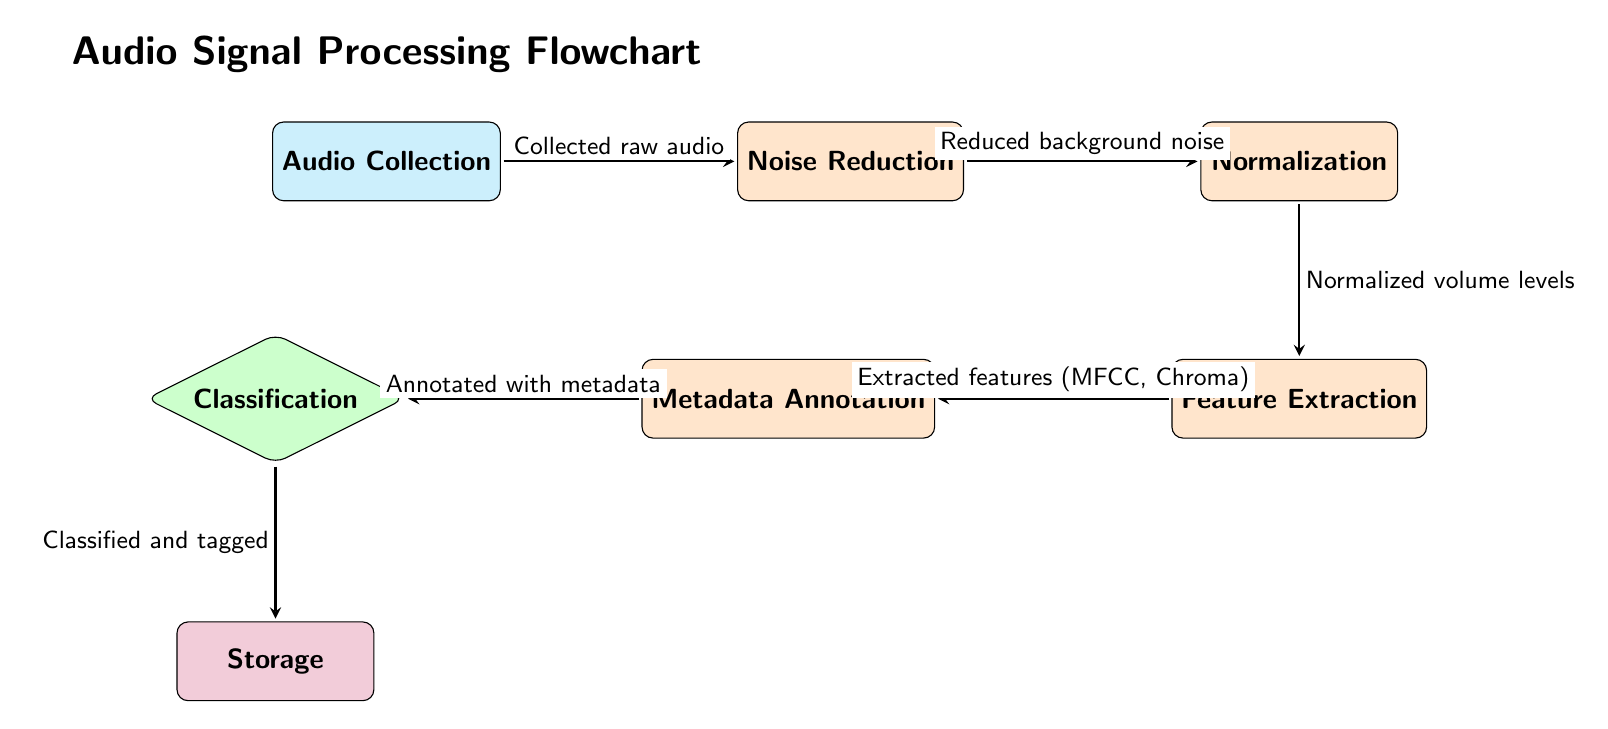What is the first step in the audio processing flow? The first step is "Audio Collection," as indicated by the leftmost node in the diagram.
Answer: Audio Collection How many processes are involved in this flowchart? There are four processes shown: Noise Reduction, Normalization, Feature Extraction, and Metadata Annotation, which can be counted directly from the process nodes.
Answer: 4 What is the output after classification? The output after classification is "Storage," which is the final node in the diagram connected to the classification decision node.
Answer: Storage Which process follows noise reduction? Following noise reduction, the next process is "Normalization," which is directly to the right of "Noise Reduction" in the flowchart.
Answer: Normalization What type of node is "Classification"? "Classification" is a decision node, indicated by its diamond shape and color in the diagram.
Answer: Decision What kind of features are extracted during the feature extraction process? The features extracted during this process are "MFCC" and "Chroma," which are mentioned by the arrow leading to the Metadata Annotation node.
Answer: MFCC, Chroma What is the purpose of the metadata annotation step? The purpose of the metadata annotation step is to annotate with metadata, which is indicated by the label on the arrow going into the classification node.
Answer: Annotated with metadata How many edges (arrows) are shown in this diagram? There are five edges (arrows) connecting the nodes, which can be counted by observing each arrow leading from one node to another.
Answer: 5 What is the relationship between feature extraction and metadata annotation? The relationship is that "Feature Extraction" feeds into "Metadata Annotation," illustrated by the arrow that points from one to the other.
Answer: Feeds into 